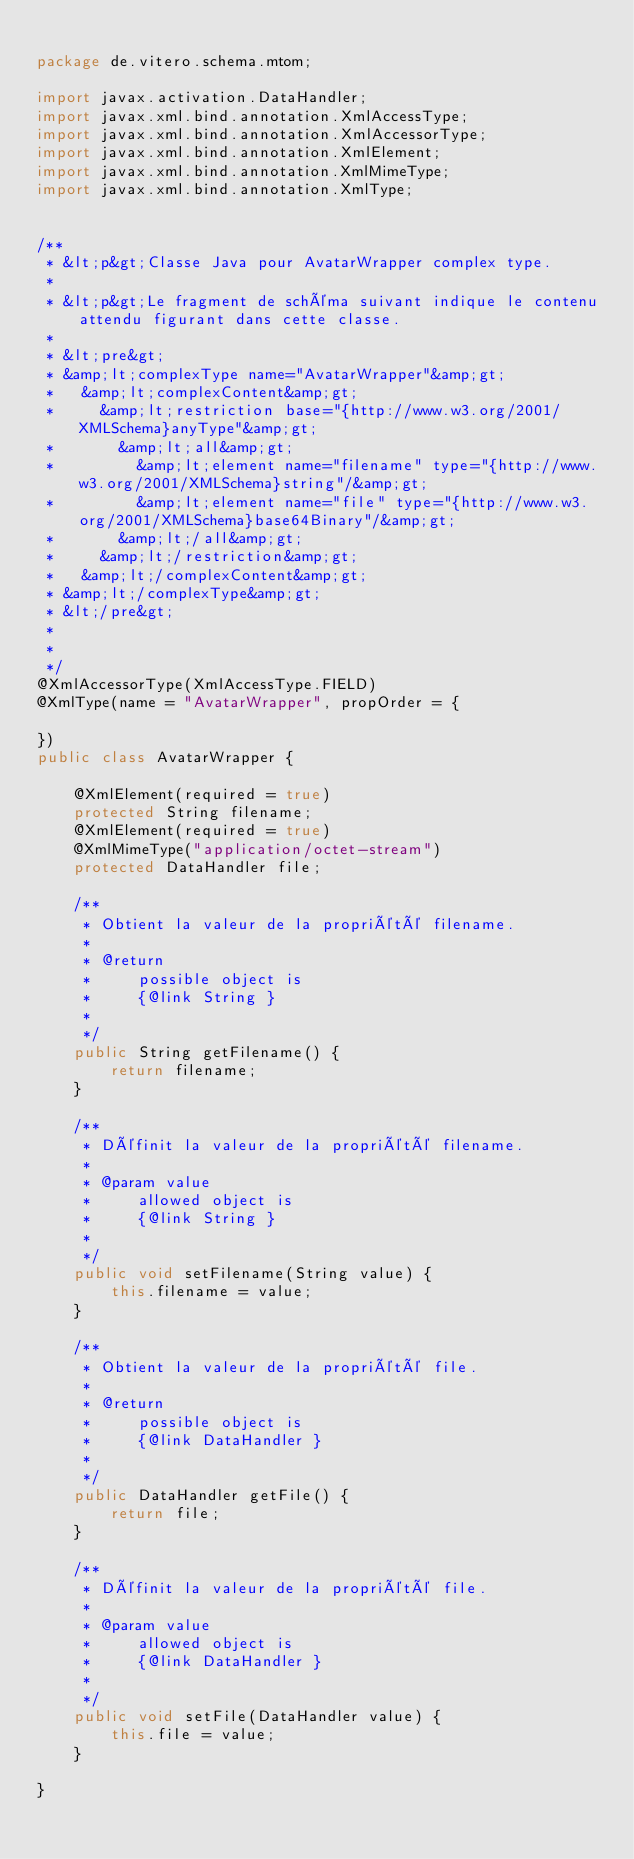Convert code to text. <code><loc_0><loc_0><loc_500><loc_500><_Java_>
package de.vitero.schema.mtom;

import javax.activation.DataHandler;
import javax.xml.bind.annotation.XmlAccessType;
import javax.xml.bind.annotation.XmlAccessorType;
import javax.xml.bind.annotation.XmlElement;
import javax.xml.bind.annotation.XmlMimeType;
import javax.xml.bind.annotation.XmlType;


/**
 * &lt;p&gt;Classe Java pour AvatarWrapper complex type.
 * 
 * &lt;p&gt;Le fragment de schéma suivant indique le contenu attendu figurant dans cette classe.
 * 
 * &lt;pre&gt;
 * &amp;lt;complexType name="AvatarWrapper"&amp;gt;
 *   &amp;lt;complexContent&amp;gt;
 *     &amp;lt;restriction base="{http://www.w3.org/2001/XMLSchema}anyType"&amp;gt;
 *       &amp;lt;all&amp;gt;
 *         &amp;lt;element name="filename" type="{http://www.w3.org/2001/XMLSchema}string"/&amp;gt;
 *         &amp;lt;element name="file" type="{http://www.w3.org/2001/XMLSchema}base64Binary"/&amp;gt;
 *       &amp;lt;/all&amp;gt;
 *     &amp;lt;/restriction&amp;gt;
 *   &amp;lt;/complexContent&amp;gt;
 * &amp;lt;/complexType&amp;gt;
 * &lt;/pre&gt;
 * 
 * 
 */
@XmlAccessorType(XmlAccessType.FIELD)
@XmlType(name = "AvatarWrapper", propOrder = {

})
public class AvatarWrapper {

    @XmlElement(required = true)
    protected String filename;
    @XmlElement(required = true)
    @XmlMimeType("application/octet-stream")
    protected DataHandler file;

    /**
     * Obtient la valeur de la propriété filename.
     * 
     * @return
     *     possible object is
     *     {@link String }
     *     
     */
    public String getFilename() {
        return filename;
    }

    /**
     * Définit la valeur de la propriété filename.
     * 
     * @param value
     *     allowed object is
     *     {@link String }
     *     
     */
    public void setFilename(String value) {
        this.filename = value;
    }

    /**
     * Obtient la valeur de la propriété file.
     * 
     * @return
     *     possible object is
     *     {@link DataHandler }
     *     
     */
    public DataHandler getFile() {
        return file;
    }

    /**
     * Définit la valeur de la propriété file.
     * 
     * @param value
     *     allowed object is
     *     {@link DataHandler }
     *     
     */
    public void setFile(DataHandler value) {
        this.file = value;
    }

}
</code> 